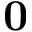Convert formula to latex. <formula><loc_0><loc_0><loc_500><loc_500>{ 0 }</formula> 